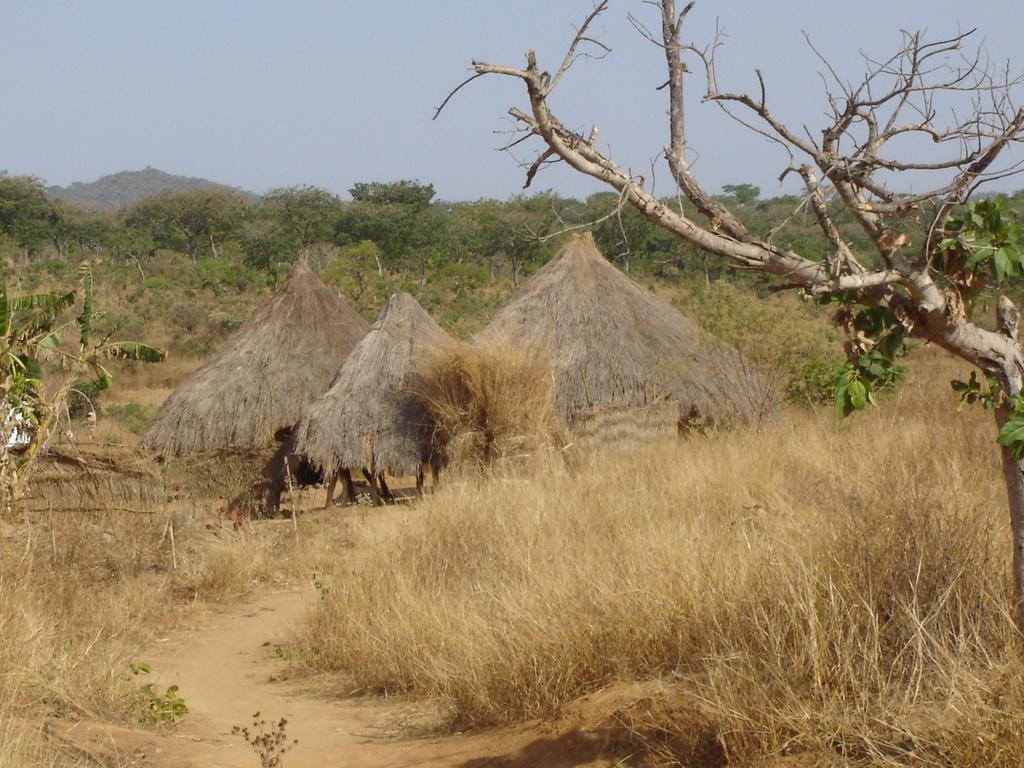In one or two sentences, can you explain what this image depicts? In this image there is grass, in the middle there are three huts, in the background there are trees and a sky. 